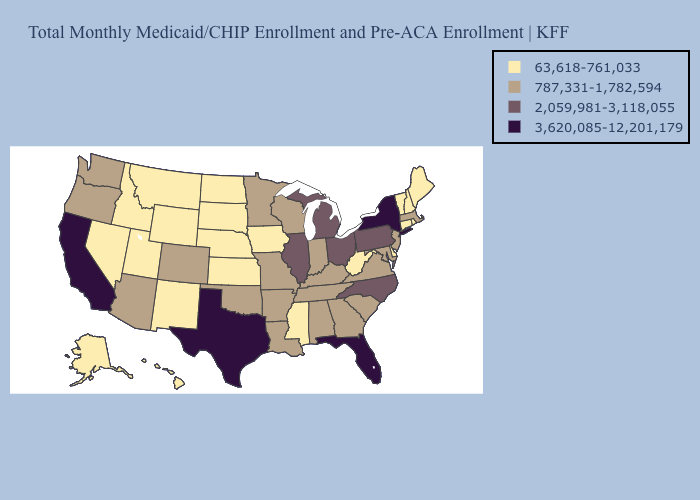Does Indiana have a lower value than New Hampshire?
Keep it brief. No. Among the states that border New York , which have the lowest value?
Give a very brief answer. Connecticut, Vermont. Name the states that have a value in the range 3,620,085-12,201,179?
Keep it brief. California, Florida, New York, Texas. Name the states that have a value in the range 2,059,981-3,118,055?
Be succinct. Illinois, Michigan, North Carolina, Ohio, Pennsylvania. Which states have the lowest value in the USA?
Be succinct. Alaska, Connecticut, Delaware, Hawaii, Idaho, Iowa, Kansas, Maine, Mississippi, Montana, Nebraska, Nevada, New Hampshire, New Mexico, North Dakota, Rhode Island, South Dakota, Utah, Vermont, West Virginia, Wyoming. Does Missouri have the highest value in the MidWest?
Keep it brief. No. Does South Carolina have the lowest value in the South?
Concise answer only. No. Does Rhode Island have the same value as Minnesota?
Concise answer only. No. Is the legend a continuous bar?
Be succinct. No. Among the states that border Wyoming , does Utah have the highest value?
Be succinct. No. Among the states that border New Jersey , does Delaware have the lowest value?
Concise answer only. Yes. What is the lowest value in the Northeast?
Write a very short answer. 63,618-761,033. Does Maryland have the highest value in the South?
Keep it brief. No. How many symbols are there in the legend?
Give a very brief answer. 4. Does New York have the highest value in the USA?
Give a very brief answer. Yes. 